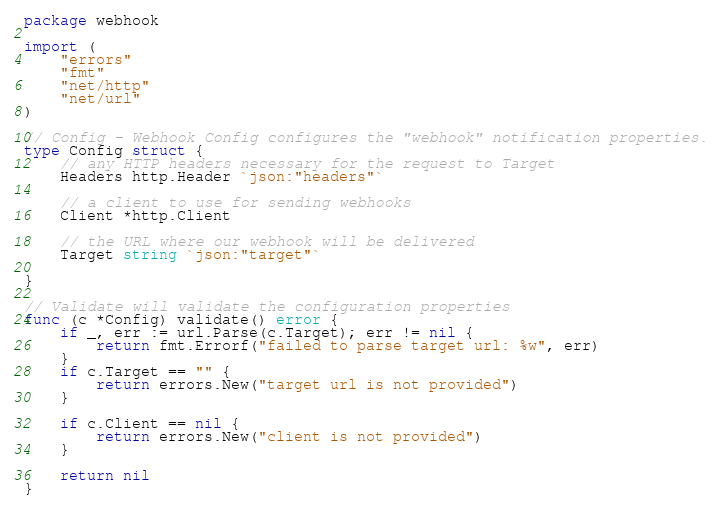<code> <loc_0><loc_0><loc_500><loc_500><_Go_>package webhook

import (
	"errors"
	"fmt"
	"net/http"
	"net/url"
)

// Config - Webhook Config configures the "webhook" notification properties.
type Config struct {
	// any HTTP headers necessary for the request to Target
	Headers http.Header `json:"headers"`

	// a client to use for sending webhooks
	Client *http.Client

	// the URL where our webhook will be delivered
	Target string `json:"target"`

}

// Validate will validate the configuration properties
func (c *Config) validate() error {
	if _, err := url.Parse(c.Target); err != nil {
		return fmt.Errorf("failed to parse target url: %w", err)
	}
	if c.Target == "" {
		return errors.New("target url is not provided")
	}

	if c.Client == nil {
		return errors.New("client is not provided")
	}

	return nil
}
</code> 